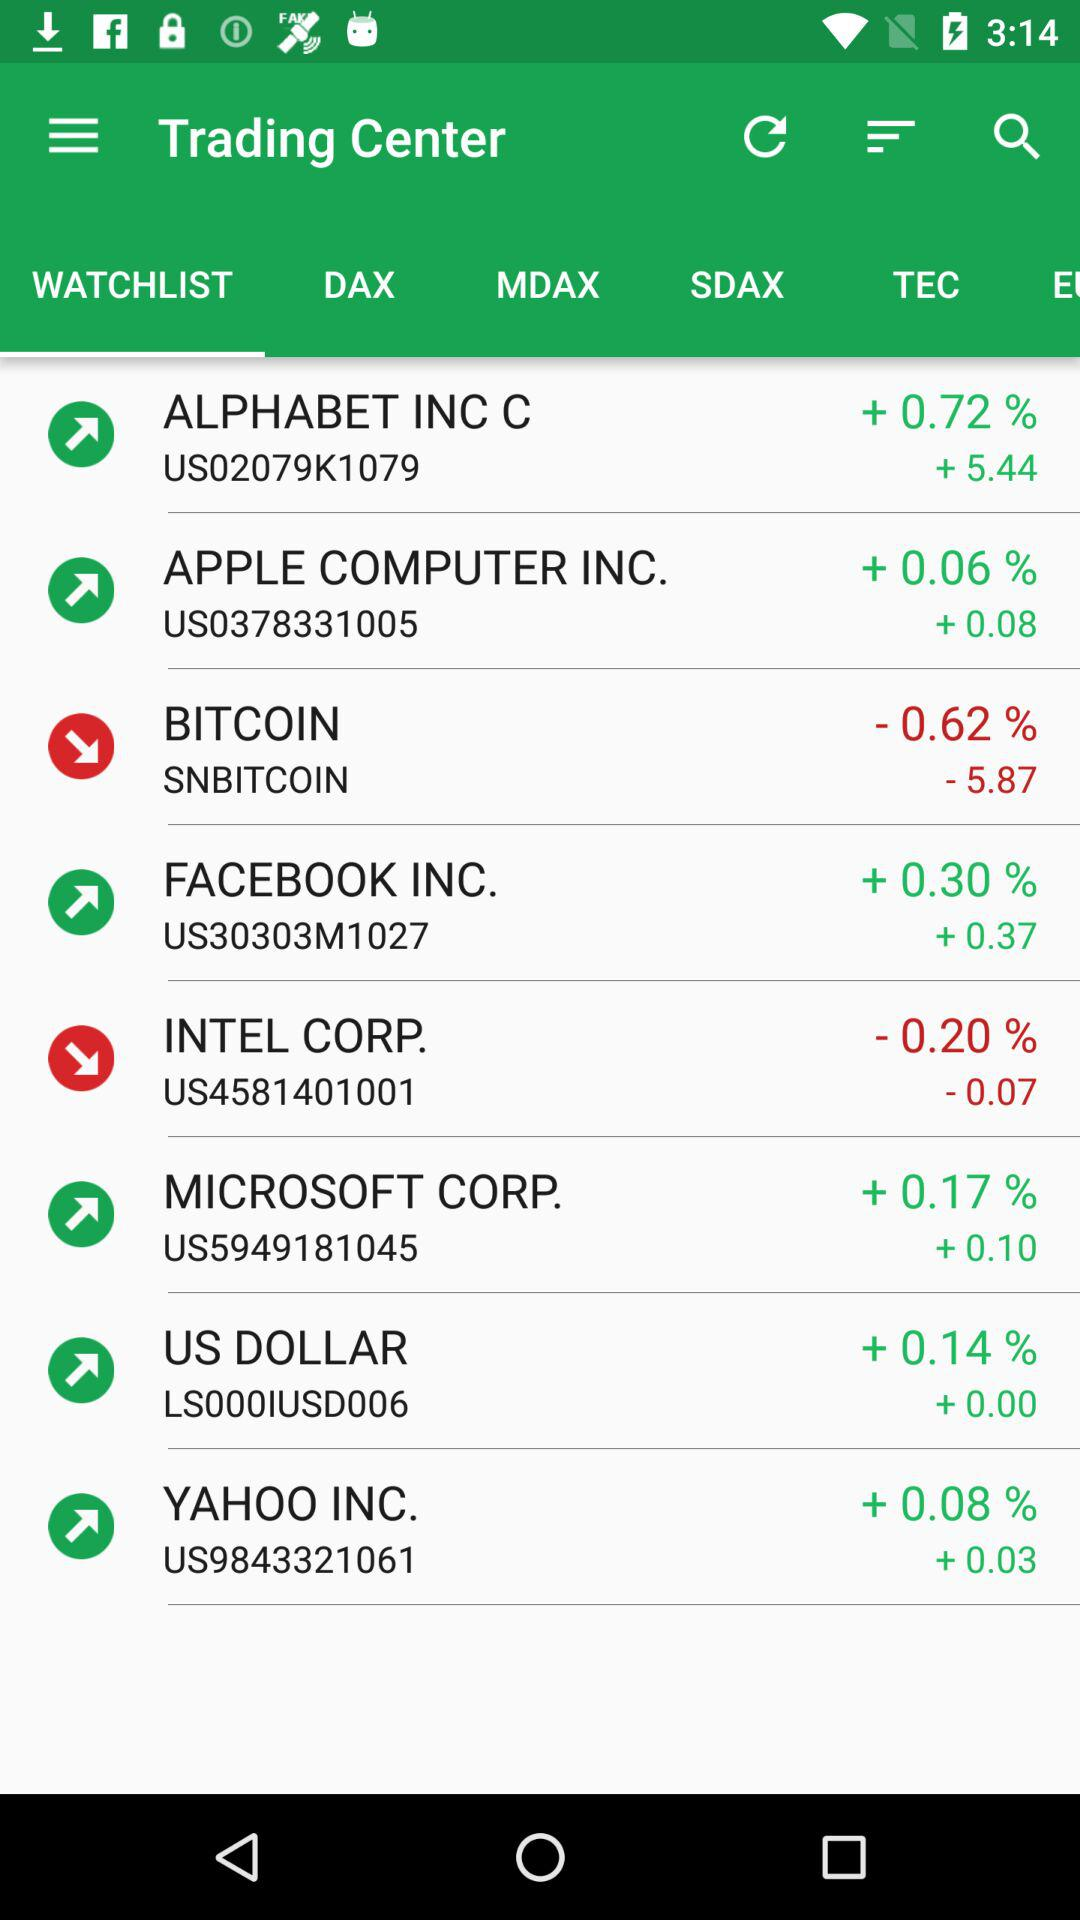How many notifications are there in "SDAX"?
When the provided information is insufficient, respond with <no answer>. <no answer> 